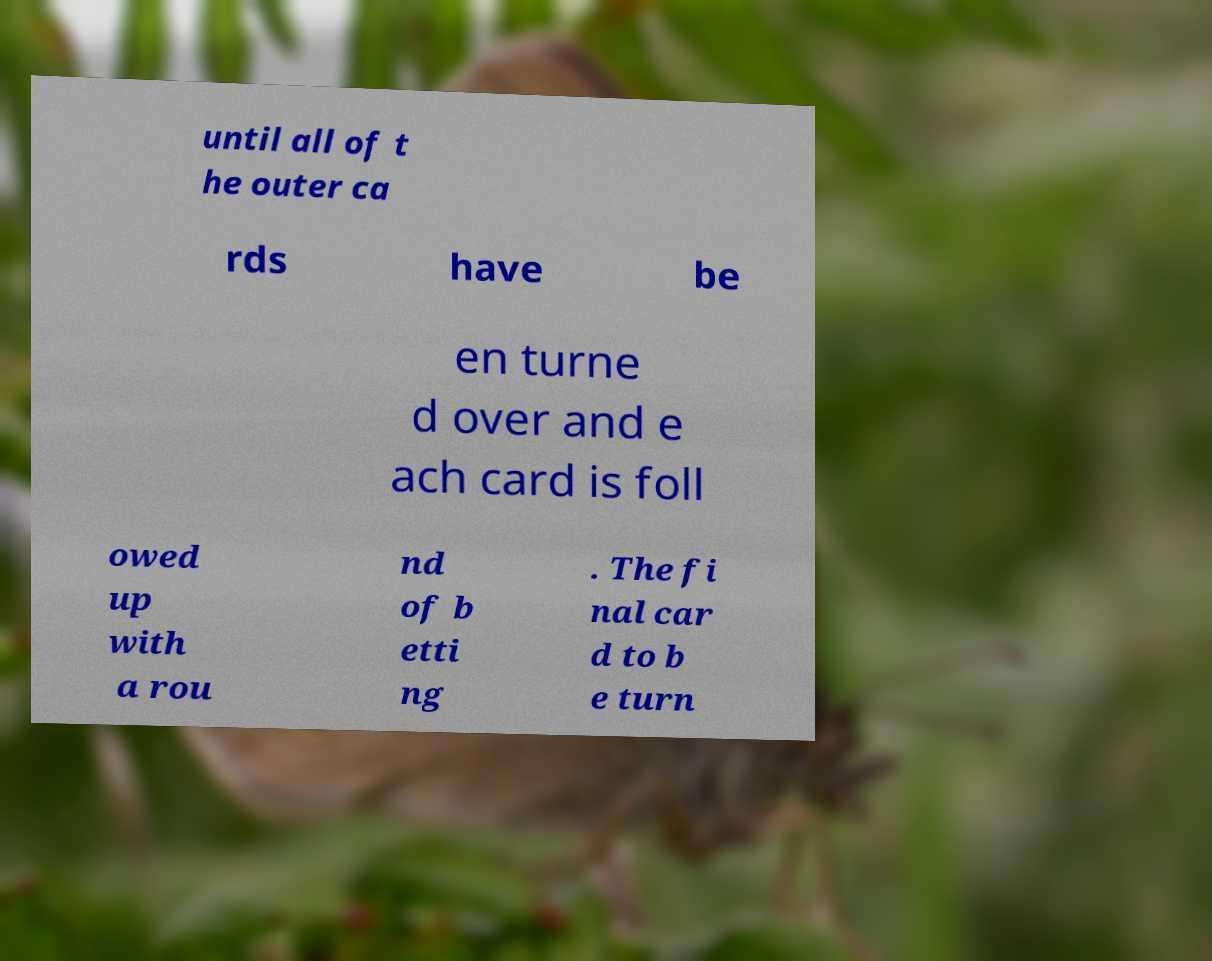Can you accurately transcribe the text from the provided image for me? until all of t he outer ca rds have be en turne d over and e ach card is foll owed up with a rou nd of b etti ng . The fi nal car d to b e turn 